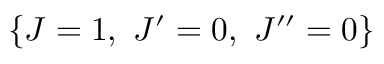Convert formula to latex. <formula><loc_0><loc_0><loc_500><loc_500>\left \{ J = 1 , \ J ^ { \prime } = 0 , \ J ^ { \prime \prime } = 0 \right \}</formula> 